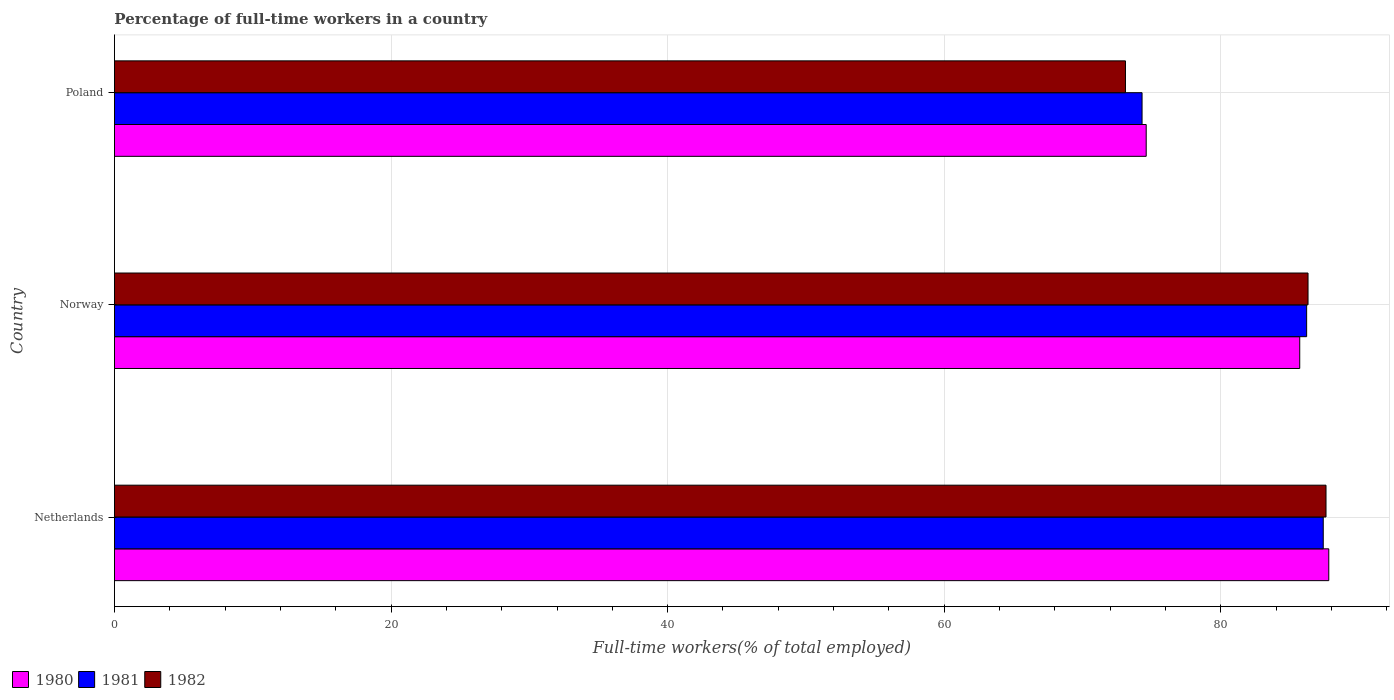How many groups of bars are there?
Make the answer very short. 3. Are the number of bars on each tick of the Y-axis equal?
Your answer should be compact. Yes. How many bars are there on the 3rd tick from the top?
Your answer should be very brief. 3. How many bars are there on the 2nd tick from the bottom?
Provide a succinct answer. 3. What is the label of the 3rd group of bars from the top?
Your answer should be compact. Netherlands. In how many cases, is the number of bars for a given country not equal to the number of legend labels?
Ensure brevity in your answer.  0. What is the percentage of full-time workers in 1982 in Poland?
Keep it short and to the point. 73.1. Across all countries, what is the maximum percentage of full-time workers in 1982?
Provide a succinct answer. 87.6. Across all countries, what is the minimum percentage of full-time workers in 1981?
Offer a very short reply. 74.3. In which country was the percentage of full-time workers in 1981 maximum?
Your answer should be very brief. Netherlands. In which country was the percentage of full-time workers in 1982 minimum?
Your answer should be very brief. Poland. What is the total percentage of full-time workers in 1982 in the graph?
Your response must be concise. 247. What is the difference between the percentage of full-time workers in 1982 in Netherlands and that in Poland?
Give a very brief answer. 14.5. What is the difference between the percentage of full-time workers in 1981 in Poland and the percentage of full-time workers in 1980 in Norway?
Provide a succinct answer. -11.4. What is the average percentage of full-time workers in 1982 per country?
Provide a succinct answer. 82.33. What is the difference between the percentage of full-time workers in 1980 and percentage of full-time workers in 1982 in Netherlands?
Provide a succinct answer. 0.2. In how many countries, is the percentage of full-time workers in 1980 greater than 24 %?
Your answer should be very brief. 3. What is the ratio of the percentage of full-time workers in 1981 in Netherlands to that in Norway?
Your answer should be very brief. 1.01. What is the difference between the highest and the second highest percentage of full-time workers in 1982?
Offer a very short reply. 1.3. What is the difference between the highest and the lowest percentage of full-time workers in 1981?
Make the answer very short. 13.1. In how many countries, is the percentage of full-time workers in 1981 greater than the average percentage of full-time workers in 1981 taken over all countries?
Make the answer very short. 2. Is the sum of the percentage of full-time workers in 1981 in Netherlands and Poland greater than the maximum percentage of full-time workers in 1982 across all countries?
Ensure brevity in your answer.  Yes. What does the 3rd bar from the bottom in Netherlands represents?
Your response must be concise. 1982. Are all the bars in the graph horizontal?
Give a very brief answer. Yes. What is the difference between two consecutive major ticks on the X-axis?
Your response must be concise. 20. Are the values on the major ticks of X-axis written in scientific E-notation?
Your answer should be compact. No. Does the graph contain any zero values?
Make the answer very short. No. Does the graph contain grids?
Your answer should be compact. Yes. How many legend labels are there?
Make the answer very short. 3. What is the title of the graph?
Offer a terse response. Percentage of full-time workers in a country. What is the label or title of the X-axis?
Offer a terse response. Full-time workers(% of total employed). What is the label or title of the Y-axis?
Make the answer very short. Country. What is the Full-time workers(% of total employed) in 1980 in Netherlands?
Your response must be concise. 87.8. What is the Full-time workers(% of total employed) of 1981 in Netherlands?
Your response must be concise. 87.4. What is the Full-time workers(% of total employed) in 1982 in Netherlands?
Provide a succinct answer. 87.6. What is the Full-time workers(% of total employed) of 1980 in Norway?
Your answer should be compact. 85.7. What is the Full-time workers(% of total employed) in 1981 in Norway?
Offer a very short reply. 86.2. What is the Full-time workers(% of total employed) of 1982 in Norway?
Your answer should be compact. 86.3. What is the Full-time workers(% of total employed) of 1980 in Poland?
Keep it short and to the point. 74.6. What is the Full-time workers(% of total employed) of 1981 in Poland?
Make the answer very short. 74.3. What is the Full-time workers(% of total employed) of 1982 in Poland?
Keep it short and to the point. 73.1. Across all countries, what is the maximum Full-time workers(% of total employed) of 1980?
Your answer should be very brief. 87.8. Across all countries, what is the maximum Full-time workers(% of total employed) of 1981?
Your response must be concise. 87.4. Across all countries, what is the maximum Full-time workers(% of total employed) of 1982?
Your response must be concise. 87.6. Across all countries, what is the minimum Full-time workers(% of total employed) in 1980?
Offer a terse response. 74.6. Across all countries, what is the minimum Full-time workers(% of total employed) in 1981?
Make the answer very short. 74.3. Across all countries, what is the minimum Full-time workers(% of total employed) of 1982?
Give a very brief answer. 73.1. What is the total Full-time workers(% of total employed) of 1980 in the graph?
Provide a succinct answer. 248.1. What is the total Full-time workers(% of total employed) in 1981 in the graph?
Give a very brief answer. 247.9. What is the total Full-time workers(% of total employed) of 1982 in the graph?
Make the answer very short. 247. What is the difference between the Full-time workers(% of total employed) in 1980 in Netherlands and that in Norway?
Make the answer very short. 2.1. What is the difference between the Full-time workers(% of total employed) of 1980 in Netherlands and that in Poland?
Provide a short and direct response. 13.2. What is the difference between the Full-time workers(% of total employed) in 1980 in Norway and that in Poland?
Offer a very short reply. 11.1. What is the difference between the Full-time workers(% of total employed) of 1981 in Norway and that in Poland?
Your answer should be very brief. 11.9. What is the difference between the Full-time workers(% of total employed) of 1982 in Norway and that in Poland?
Your response must be concise. 13.2. What is the difference between the Full-time workers(% of total employed) in 1980 in Netherlands and the Full-time workers(% of total employed) in 1982 in Norway?
Offer a terse response. 1.5. What is the difference between the Full-time workers(% of total employed) in 1981 in Netherlands and the Full-time workers(% of total employed) in 1982 in Norway?
Offer a terse response. 1.1. What is the difference between the Full-time workers(% of total employed) in 1980 in Netherlands and the Full-time workers(% of total employed) in 1981 in Poland?
Your response must be concise. 13.5. What is the difference between the Full-time workers(% of total employed) in 1980 in Netherlands and the Full-time workers(% of total employed) in 1982 in Poland?
Offer a very short reply. 14.7. What is the difference between the Full-time workers(% of total employed) of 1981 in Netherlands and the Full-time workers(% of total employed) of 1982 in Poland?
Make the answer very short. 14.3. What is the difference between the Full-time workers(% of total employed) of 1980 in Norway and the Full-time workers(% of total employed) of 1981 in Poland?
Provide a short and direct response. 11.4. What is the average Full-time workers(% of total employed) in 1980 per country?
Make the answer very short. 82.7. What is the average Full-time workers(% of total employed) in 1981 per country?
Your answer should be very brief. 82.63. What is the average Full-time workers(% of total employed) of 1982 per country?
Your answer should be very brief. 82.33. What is the difference between the Full-time workers(% of total employed) in 1981 and Full-time workers(% of total employed) in 1982 in Netherlands?
Give a very brief answer. -0.2. What is the difference between the Full-time workers(% of total employed) of 1980 and Full-time workers(% of total employed) of 1982 in Norway?
Offer a terse response. -0.6. What is the difference between the Full-time workers(% of total employed) of 1981 and Full-time workers(% of total employed) of 1982 in Norway?
Provide a short and direct response. -0.1. What is the difference between the Full-time workers(% of total employed) of 1980 and Full-time workers(% of total employed) of 1982 in Poland?
Make the answer very short. 1.5. What is the ratio of the Full-time workers(% of total employed) in 1980 in Netherlands to that in Norway?
Make the answer very short. 1.02. What is the ratio of the Full-time workers(% of total employed) in 1981 in Netherlands to that in Norway?
Provide a short and direct response. 1.01. What is the ratio of the Full-time workers(% of total employed) of 1982 in Netherlands to that in Norway?
Offer a very short reply. 1.02. What is the ratio of the Full-time workers(% of total employed) of 1980 in Netherlands to that in Poland?
Your response must be concise. 1.18. What is the ratio of the Full-time workers(% of total employed) of 1981 in Netherlands to that in Poland?
Give a very brief answer. 1.18. What is the ratio of the Full-time workers(% of total employed) in 1982 in Netherlands to that in Poland?
Keep it short and to the point. 1.2. What is the ratio of the Full-time workers(% of total employed) of 1980 in Norway to that in Poland?
Your answer should be very brief. 1.15. What is the ratio of the Full-time workers(% of total employed) of 1981 in Norway to that in Poland?
Give a very brief answer. 1.16. What is the ratio of the Full-time workers(% of total employed) in 1982 in Norway to that in Poland?
Your answer should be compact. 1.18. What is the difference between the highest and the second highest Full-time workers(% of total employed) in 1981?
Give a very brief answer. 1.2. What is the difference between the highest and the lowest Full-time workers(% of total employed) in 1981?
Give a very brief answer. 13.1. What is the difference between the highest and the lowest Full-time workers(% of total employed) of 1982?
Keep it short and to the point. 14.5. 